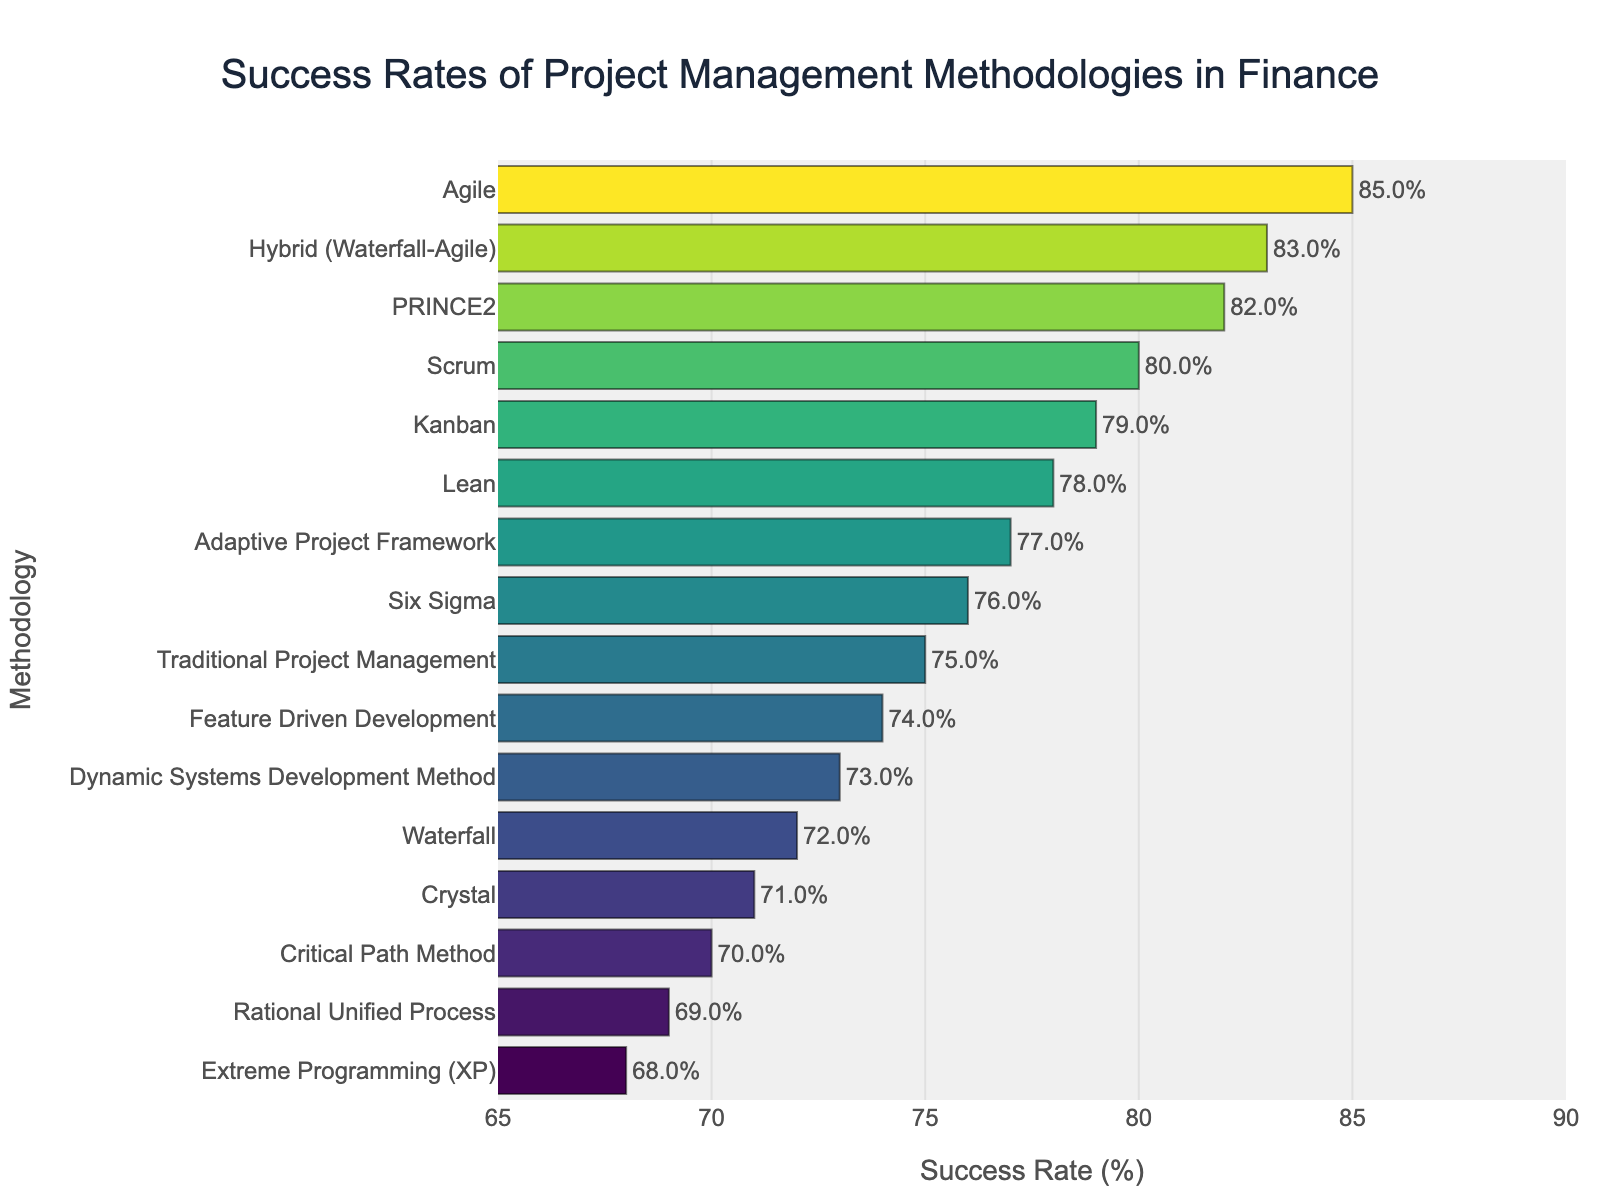Which methodology has the highest success rate? Look for the bar with the highest value along the x-axis. Agile shows the highest success rate of 85%.
Answer: Agile Which methodology has the lowest success rate? Look for the bar with the lowest value along the x-axis. Extreme Programming (XP) has the lowest success rate of 68%.
Answer: Extreme Programming (XP) How many methodologies have a success rate over 80%? Identify and count the bars that extend beyond the 80% mark on the x-axis. The methodologies are Agile (85%), PRINCE2 (82%), Hybrid (Waterfall-Agile) (83%), and Scrum (80%). There are 4 bars in total.
Answer: 4 Which methodologies have success rates within 5% of each other? Check the difference between the success rates of neighboring bars in the sorted chart. Scrum (80%) and PRINCE2 (82%) have a difference of 2%. Lean (78%), Six Sigma (76%), and PRINCE2 (82%) have differences within 5%. Other pairs within 5% are Kanban (79%) and Lean (78%), Traditional Project Management (75%) and Adaptive Project Framework (77%), Lean (78%) and Six Sigma (76%), Crystal (71%) and Feature Driven Development (74%), Dynamic Systems Development Method (73%) and Crystal (71%).
Answer: Scrum & PRINCE2; Lean, Six Sigma & PRINCE2; Kanban & Lean; Traditional Project Management & Adaptive Project Framework; Lean & Six Sigma; Crystal & Feature Driven Development; Dynamic Systems Development Method & Crystal What is the average success rate of Agile, Scrum, and Kanban? Add the success rates of Agile (85%), Scrum (80%), and Kanban (79%). Then, divide the sum by the number of methodologies. (85 + 80 + 79) / 3 = 244 / 3. The average success rate is approximately 81.33%.
Answer: 81.33% What is the difference in success rates between the highest and lowest methodologies? Subtract the lowest success rate from the highest. Agile has the highest success rate of 85%, and Extreme Programming (XP) has the lowest at 68%. 85 - 68 = 17. The difference is 17%.
Answer: 17% How does the success rate of PRINCE2 compare to that of Critical Path Method? Compare the success rates of PRINCE2 (82%) and Critical Path Method (70%). PRINCE2 has a 12% higher success rate than Critical Path Method.
Answer: PRINCE2 is 12% higher What is the combined success rate of Lean, Six Sigma, and Traditional Project Management? Sum the success rates of Lean (78%), Six Sigma (76%), and Traditional Project Management (75%). 78 + 76 + 75 = 229. The combined success rate is 229%.
Answer: 229% Is the success rate of Hybrid (Waterfall-Agile) closer to that of Scrum or Agile? Find the absolute difference between Hybrid (Waterfall-Agile) (83%) and Scrum (80%) as well as Hybrid (Waterfall-Agile) and Agile (85%). 83 - 80 = 3 and 85 - 83 = 2. The success rate of Hybrid (Waterfall-Agile) is closer to Agile (2% difference) than to Scrum (3% difference).
Answer: Agile Which methodology has a success rate exactly equal to the median in this data set? Sort the success rates and find the middle one. Since there are 16 methodologies, the median will be the average of the 8th and 9th values in the sorted list. The sorted list of success rates is: [68, 69, 70, 71, 72, 73, 74, 75, 76, 77, 78, 79, 80, 82, 83, 85]. The middle two values are 75 and 76, so the median is (75+76)/2 = 75.5%. Traditional Project Management exactly has a success rate of 75%.
Answer: Traditional Project Management 